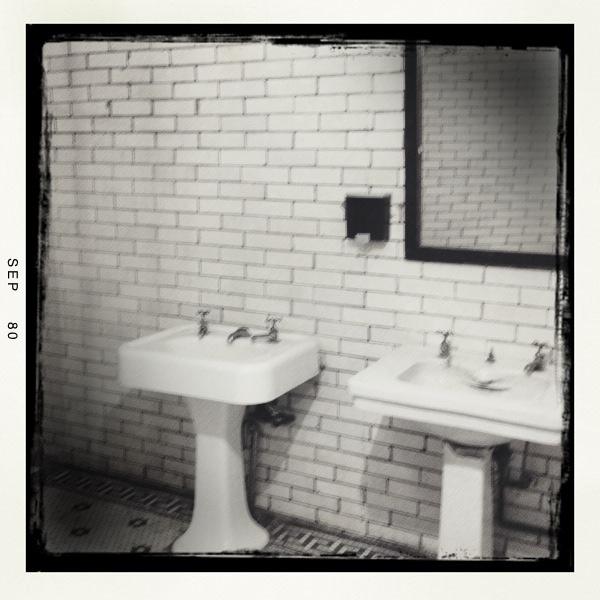How many sinks are there?
Keep it brief. 2. What are the walls made of?
Quick response, please. Brick. What is the date on the photo?
Short answer required. Sep 80. What kind of room is this?
Short answer required. Bathroom. How many sinks are in the room?
Write a very short answer. 2. 